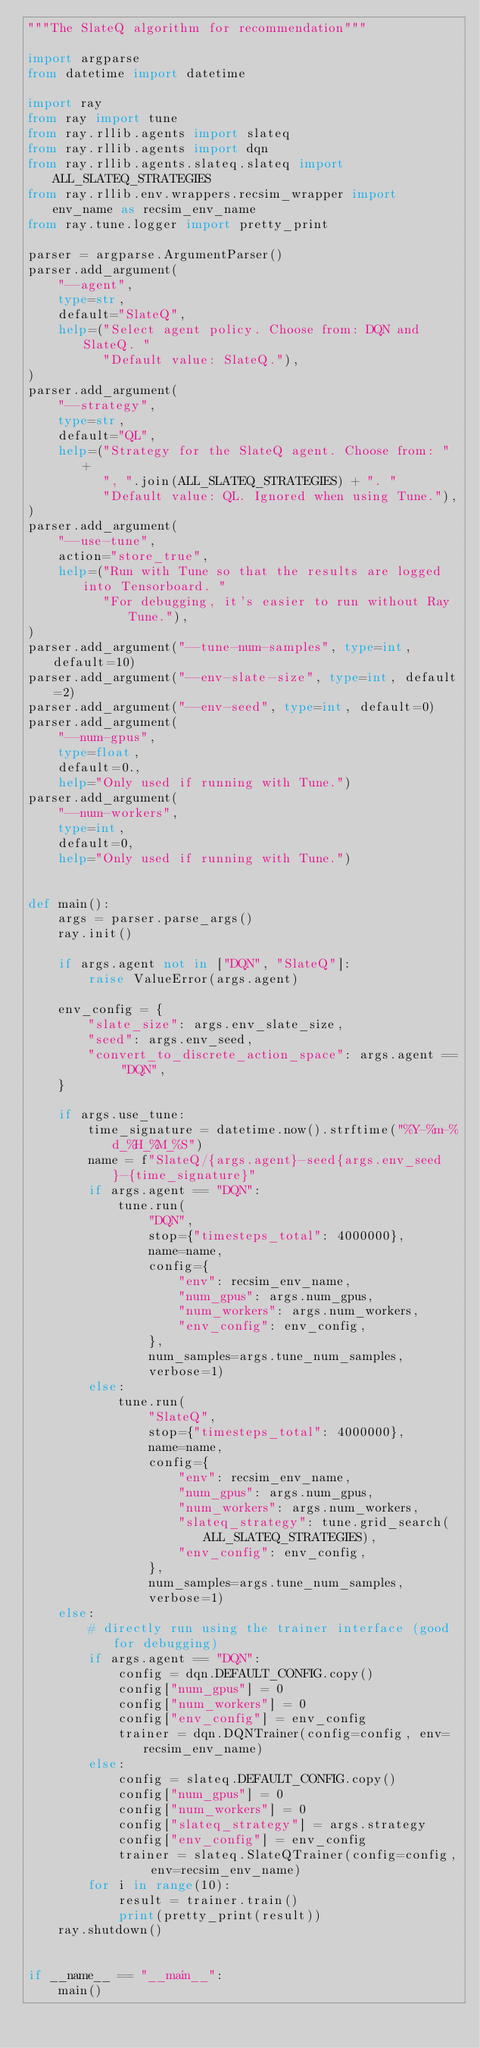<code> <loc_0><loc_0><loc_500><loc_500><_Python_>"""The SlateQ algorithm for recommendation"""

import argparse
from datetime import datetime

import ray
from ray import tune
from ray.rllib.agents import slateq
from ray.rllib.agents import dqn
from ray.rllib.agents.slateq.slateq import ALL_SLATEQ_STRATEGIES
from ray.rllib.env.wrappers.recsim_wrapper import env_name as recsim_env_name
from ray.tune.logger import pretty_print

parser = argparse.ArgumentParser()
parser.add_argument(
    "--agent",
    type=str,
    default="SlateQ",
    help=("Select agent policy. Choose from: DQN and SlateQ. "
          "Default value: SlateQ."),
)
parser.add_argument(
    "--strategy",
    type=str,
    default="QL",
    help=("Strategy for the SlateQ agent. Choose from: " +
          ", ".join(ALL_SLATEQ_STRATEGIES) + ". "
          "Default value: QL. Ignored when using Tune."),
)
parser.add_argument(
    "--use-tune",
    action="store_true",
    help=("Run with Tune so that the results are logged into Tensorboard. "
          "For debugging, it's easier to run without Ray Tune."),
)
parser.add_argument("--tune-num-samples", type=int, default=10)
parser.add_argument("--env-slate-size", type=int, default=2)
parser.add_argument("--env-seed", type=int, default=0)
parser.add_argument(
    "--num-gpus",
    type=float,
    default=0.,
    help="Only used if running with Tune.")
parser.add_argument(
    "--num-workers",
    type=int,
    default=0,
    help="Only used if running with Tune.")


def main():
    args = parser.parse_args()
    ray.init()

    if args.agent not in ["DQN", "SlateQ"]:
        raise ValueError(args.agent)

    env_config = {
        "slate_size": args.env_slate_size,
        "seed": args.env_seed,
        "convert_to_discrete_action_space": args.agent == "DQN",
    }

    if args.use_tune:
        time_signature = datetime.now().strftime("%Y-%m-%d_%H_%M_%S")
        name = f"SlateQ/{args.agent}-seed{args.env_seed}-{time_signature}"
        if args.agent == "DQN":
            tune.run(
                "DQN",
                stop={"timesteps_total": 4000000},
                name=name,
                config={
                    "env": recsim_env_name,
                    "num_gpus": args.num_gpus,
                    "num_workers": args.num_workers,
                    "env_config": env_config,
                },
                num_samples=args.tune_num_samples,
                verbose=1)
        else:
            tune.run(
                "SlateQ",
                stop={"timesteps_total": 4000000},
                name=name,
                config={
                    "env": recsim_env_name,
                    "num_gpus": args.num_gpus,
                    "num_workers": args.num_workers,
                    "slateq_strategy": tune.grid_search(ALL_SLATEQ_STRATEGIES),
                    "env_config": env_config,
                },
                num_samples=args.tune_num_samples,
                verbose=1)
    else:
        # directly run using the trainer interface (good for debugging)
        if args.agent == "DQN":
            config = dqn.DEFAULT_CONFIG.copy()
            config["num_gpus"] = 0
            config["num_workers"] = 0
            config["env_config"] = env_config
            trainer = dqn.DQNTrainer(config=config, env=recsim_env_name)
        else:
            config = slateq.DEFAULT_CONFIG.copy()
            config["num_gpus"] = 0
            config["num_workers"] = 0
            config["slateq_strategy"] = args.strategy
            config["env_config"] = env_config
            trainer = slateq.SlateQTrainer(config=config, env=recsim_env_name)
        for i in range(10):
            result = trainer.train()
            print(pretty_print(result))
    ray.shutdown()


if __name__ == "__main__":
    main()
</code> 